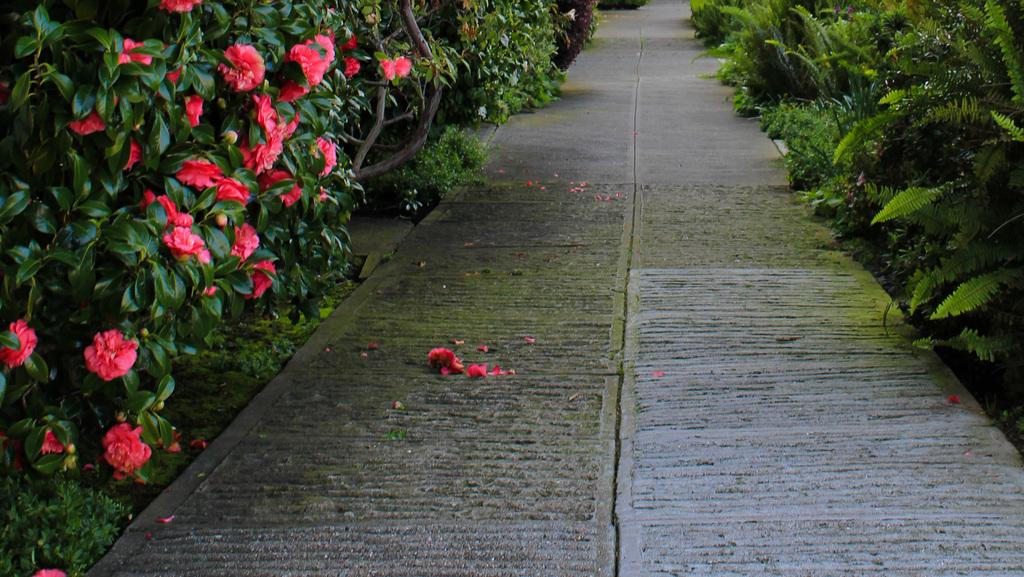What can be seen in the image that people walk on? There is a path in the image that people can walk on. What decorates the path in the image? Flowers are present on the path in the image. What else can be seen in the image besides the path? There are plants in the image. How many flowers can be seen in the image? There is at least one flower in the image. Reasoning: Let's think step by step to produce the conversation. We start by identifying the main subject in the image, which is the path. Then, we describe the decorations on the path, which are the flowers. Next, we mention other elements in the image, such as plants. Finally, we focus on the flowers and clarify that there is at least one flower present. Absurd Question/Answer: What type of ear is visible in the image? There is no ear present in the image. Can you describe the arch in the image? There is no arch present in the image. 